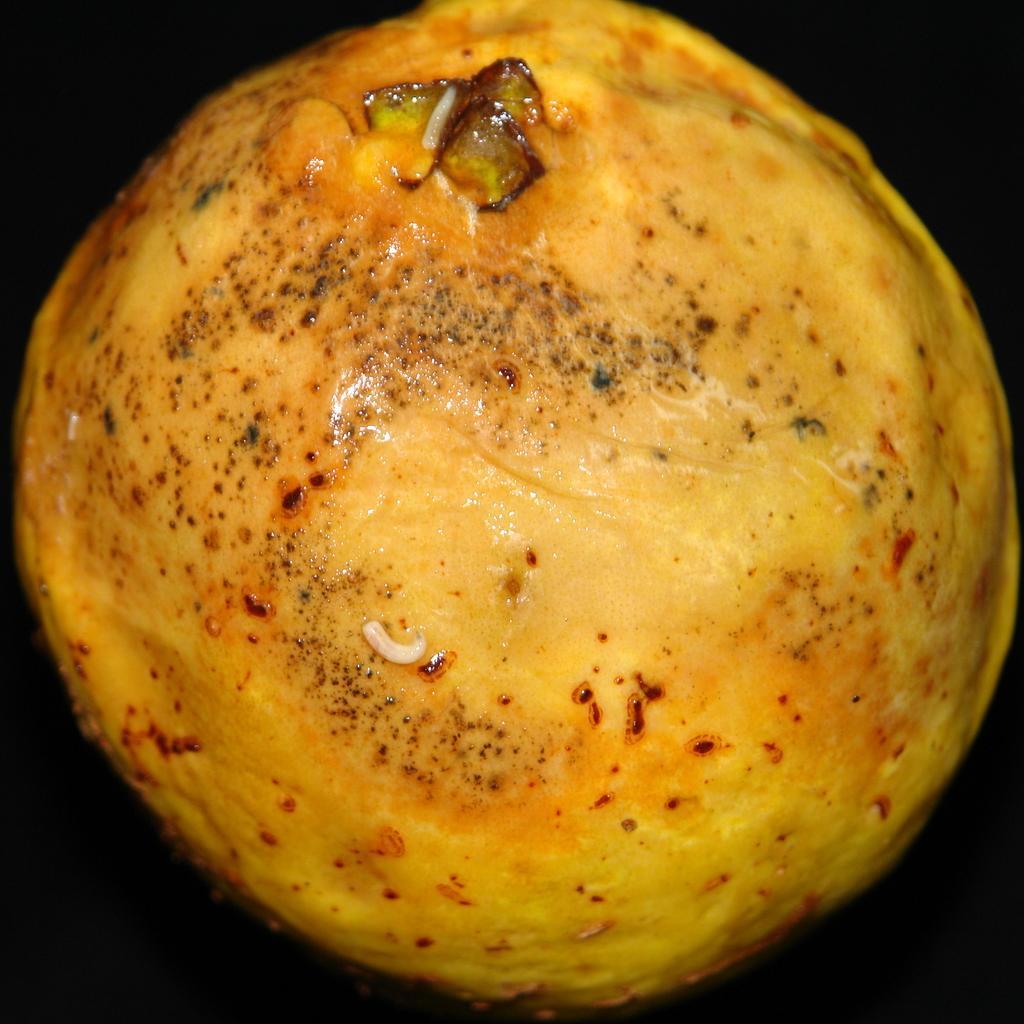Can you describe this image briefly? In the center of the image, we can see a food item. 